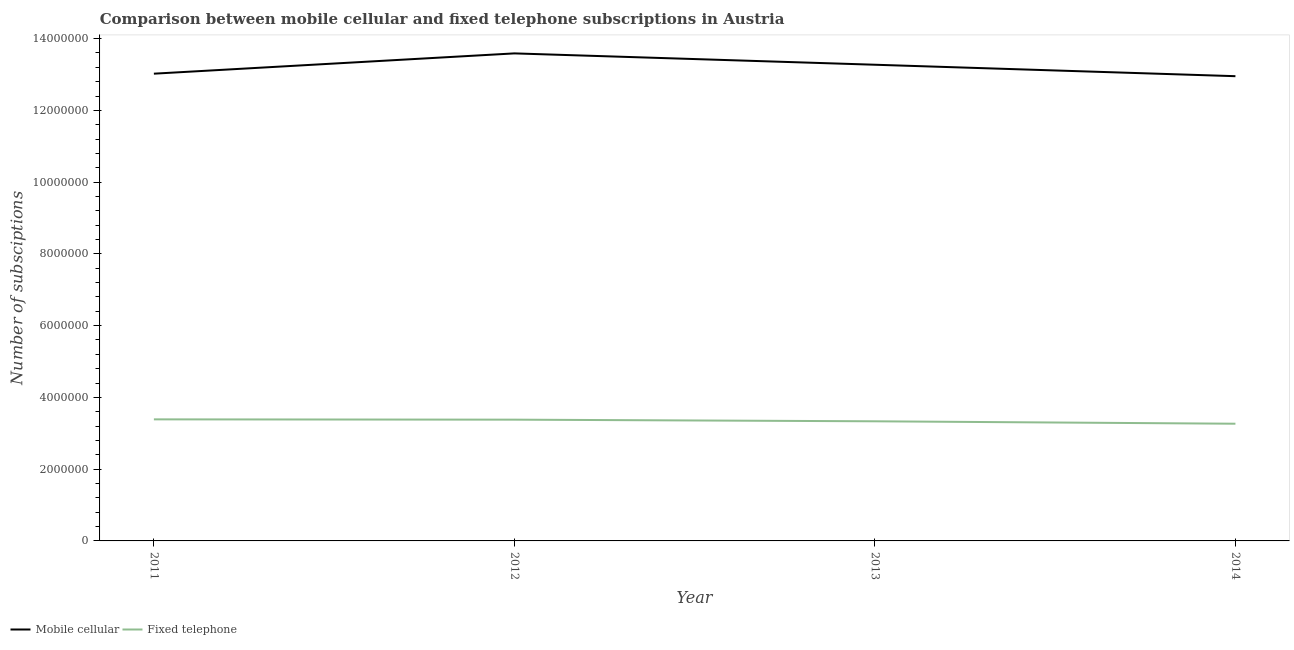Does the line corresponding to number of mobile cellular subscriptions intersect with the line corresponding to number of fixed telephone subscriptions?
Your response must be concise. No. What is the number of fixed telephone subscriptions in 2013?
Ensure brevity in your answer.  3.33e+06. Across all years, what is the maximum number of fixed telephone subscriptions?
Your answer should be compact. 3.39e+06. Across all years, what is the minimum number of fixed telephone subscriptions?
Your answer should be compact. 3.27e+06. What is the total number of fixed telephone subscriptions in the graph?
Offer a very short reply. 1.34e+07. What is the difference between the number of mobile cellular subscriptions in 2011 and that in 2013?
Your response must be concise. -2.49e+05. What is the difference between the number of mobile cellular subscriptions in 2012 and the number of fixed telephone subscriptions in 2014?
Provide a succinct answer. 1.03e+07. What is the average number of fixed telephone subscriptions per year?
Your answer should be very brief. 3.34e+06. In the year 2012, what is the difference between the number of mobile cellular subscriptions and number of fixed telephone subscriptions?
Ensure brevity in your answer.  1.02e+07. In how many years, is the number of mobile cellular subscriptions greater than 13200000?
Make the answer very short. 2. What is the ratio of the number of mobile cellular subscriptions in 2013 to that in 2014?
Ensure brevity in your answer.  1.02. What is the difference between the highest and the second highest number of fixed telephone subscriptions?
Provide a succinct answer. 8000. What is the difference between the highest and the lowest number of fixed telephone subscriptions?
Your response must be concise. 1.21e+05. In how many years, is the number of mobile cellular subscriptions greater than the average number of mobile cellular subscriptions taken over all years?
Provide a short and direct response. 2. Does the number of fixed telephone subscriptions monotonically increase over the years?
Provide a succinct answer. No. Is the number of mobile cellular subscriptions strictly less than the number of fixed telephone subscriptions over the years?
Offer a very short reply. No. How many lines are there?
Your answer should be very brief. 2. How many years are there in the graph?
Provide a short and direct response. 4. What is the difference between two consecutive major ticks on the Y-axis?
Offer a terse response. 2.00e+06. Are the values on the major ticks of Y-axis written in scientific E-notation?
Your answer should be very brief. No. Does the graph contain any zero values?
Make the answer very short. No. Does the graph contain grids?
Offer a terse response. No. What is the title of the graph?
Offer a terse response. Comparison between mobile cellular and fixed telephone subscriptions in Austria. Does "From production" appear as one of the legend labels in the graph?
Provide a short and direct response. No. What is the label or title of the X-axis?
Provide a succinct answer. Year. What is the label or title of the Y-axis?
Offer a terse response. Number of subsciptions. What is the Number of subsciptions of Mobile cellular in 2011?
Give a very brief answer. 1.30e+07. What is the Number of subsciptions in Fixed telephone in 2011?
Your response must be concise. 3.39e+06. What is the Number of subsciptions of Mobile cellular in 2012?
Provide a short and direct response. 1.36e+07. What is the Number of subsciptions in Fixed telephone in 2012?
Your answer should be compact. 3.38e+06. What is the Number of subsciptions in Mobile cellular in 2013?
Offer a very short reply. 1.33e+07. What is the Number of subsciptions in Fixed telephone in 2013?
Give a very brief answer. 3.33e+06. What is the Number of subsciptions of Mobile cellular in 2014?
Your answer should be very brief. 1.30e+07. What is the Number of subsciptions in Fixed telephone in 2014?
Ensure brevity in your answer.  3.27e+06. Across all years, what is the maximum Number of subsciptions in Mobile cellular?
Offer a terse response. 1.36e+07. Across all years, what is the maximum Number of subsciptions in Fixed telephone?
Offer a terse response. 3.39e+06. Across all years, what is the minimum Number of subsciptions in Mobile cellular?
Your response must be concise. 1.30e+07. Across all years, what is the minimum Number of subsciptions of Fixed telephone?
Your answer should be very brief. 3.27e+06. What is the total Number of subsciptions of Mobile cellular in the graph?
Give a very brief answer. 5.28e+07. What is the total Number of subsciptions in Fixed telephone in the graph?
Offer a terse response. 1.34e+07. What is the difference between the Number of subsciptions in Mobile cellular in 2011 and that in 2012?
Your answer should be compact. -5.65e+05. What is the difference between the Number of subsciptions in Fixed telephone in 2011 and that in 2012?
Provide a short and direct response. 8000. What is the difference between the Number of subsciptions in Mobile cellular in 2011 and that in 2013?
Give a very brief answer. -2.49e+05. What is the difference between the Number of subsciptions in Fixed telephone in 2011 and that in 2013?
Your answer should be very brief. 5.40e+04. What is the difference between the Number of subsciptions of Mobile cellular in 2011 and that in 2014?
Your response must be concise. 7.00e+04. What is the difference between the Number of subsciptions of Fixed telephone in 2011 and that in 2014?
Your answer should be compact. 1.21e+05. What is the difference between the Number of subsciptions of Mobile cellular in 2012 and that in 2013?
Provide a short and direct response. 3.16e+05. What is the difference between the Number of subsciptions in Fixed telephone in 2012 and that in 2013?
Your response must be concise. 4.60e+04. What is the difference between the Number of subsciptions in Mobile cellular in 2012 and that in 2014?
Your response must be concise. 6.35e+05. What is the difference between the Number of subsciptions of Fixed telephone in 2012 and that in 2014?
Provide a succinct answer. 1.13e+05. What is the difference between the Number of subsciptions in Mobile cellular in 2013 and that in 2014?
Keep it short and to the point. 3.19e+05. What is the difference between the Number of subsciptions in Fixed telephone in 2013 and that in 2014?
Make the answer very short. 6.73e+04. What is the difference between the Number of subsciptions of Mobile cellular in 2011 and the Number of subsciptions of Fixed telephone in 2012?
Your response must be concise. 9.64e+06. What is the difference between the Number of subsciptions of Mobile cellular in 2011 and the Number of subsciptions of Fixed telephone in 2013?
Provide a succinct answer. 9.69e+06. What is the difference between the Number of subsciptions in Mobile cellular in 2011 and the Number of subsciptions in Fixed telephone in 2014?
Ensure brevity in your answer.  9.76e+06. What is the difference between the Number of subsciptions in Mobile cellular in 2012 and the Number of subsciptions in Fixed telephone in 2013?
Your answer should be compact. 1.03e+07. What is the difference between the Number of subsciptions of Mobile cellular in 2012 and the Number of subsciptions of Fixed telephone in 2014?
Offer a very short reply. 1.03e+07. What is the difference between the Number of subsciptions of Mobile cellular in 2013 and the Number of subsciptions of Fixed telephone in 2014?
Make the answer very short. 1.00e+07. What is the average Number of subsciptions of Mobile cellular per year?
Keep it short and to the point. 1.32e+07. What is the average Number of subsciptions in Fixed telephone per year?
Your answer should be very brief. 3.34e+06. In the year 2011, what is the difference between the Number of subsciptions in Mobile cellular and Number of subsciptions in Fixed telephone?
Your answer should be very brief. 9.63e+06. In the year 2012, what is the difference between the Number of subsciptions in Mobile cellular and Number of subsciptions in Fixed telephone?
Provide a short and direct response. 1.02e+07. In the year 2013, what is the difference between the Number of subsciptions of Mobile cellular and Number of subsciptions of Fixed telephone?
Give a very brief answer. 9.94e+06. In the year 2014, what is the difference between the Number of subsciptions in Mobile cellular and Number of subsciptions in Fixed telephone?
Provide a succinct answer. 9.69e+06. What is the ratio of the Number of subsciptions of Mobile cellular in 2011 to that in 2012?
Give a very brief answer. 0.96. What is the ratio of the Number of subsciptions in Fixed telephone in 2011 to that in 2012?
Ensure brevity in your answer.  1. What is the ratio of the Number of subsciptions in Mobile cellular in 2011 to that in 2013?
Ensure brevity in your answer.  0.98. What is the ratio of the Number of subsciptions of Fixed telephone in 2011 to that in 2013?
Provide a succinct answer. 1.02. What is the ratio of the Number of subsciptions in Mobile cellular in 2011 to that in 2014?
Your response must be concise. 1.01. What is the ratio of the Number of subsciptions of Fixed telephone in 2011 to that in 2014?
Give a very brief answer. 1.04. What is the ratio of the Number of subsciptions of Mobile cellular in 2012 to that in 2013?
Your response must be concise. 1.02. What is the ratio of the Number of subsciptions of Fixed telephone in 2012 to that in 2013?
Offer a terse response. 1.01. What is the ratio of the Number of subsciptions of Mobile cellular in 2012 to that in 2014?
Your response must be concise. 1.05. What is the ratio of the Number of subsciptions in Fixed telephone in 2012 to that in 2014?
Offer a very short reply. 1.03. What is the ratio of the Number of subsciptions in Mobile cellular in 2013 to that in 2014?
Provide a short and direct response. 1.02. What is the ratio of the Number of subsciptions in Fixed telephone in 2013 to that in 2014?
Your answer should be very brief. 1.02. What is the difference between the highest and the second highest Number of subsciptions in Mobile cellular?
Offer a very short reply. 3.16e+05. What is the difference between the highest and the second highest Number of subsciptions of Fixed telephone?
Keep it short and to the point. 8000. What is the difference between the highest and the lowest Number of subsciptions of Mobile cellular?
Give a very brief answer. 6.35e+05. What is the difference between the highest and the lowest Number of subsciptions of Fixed telephone?
Keep it short and to the point. 1.21e+05. 